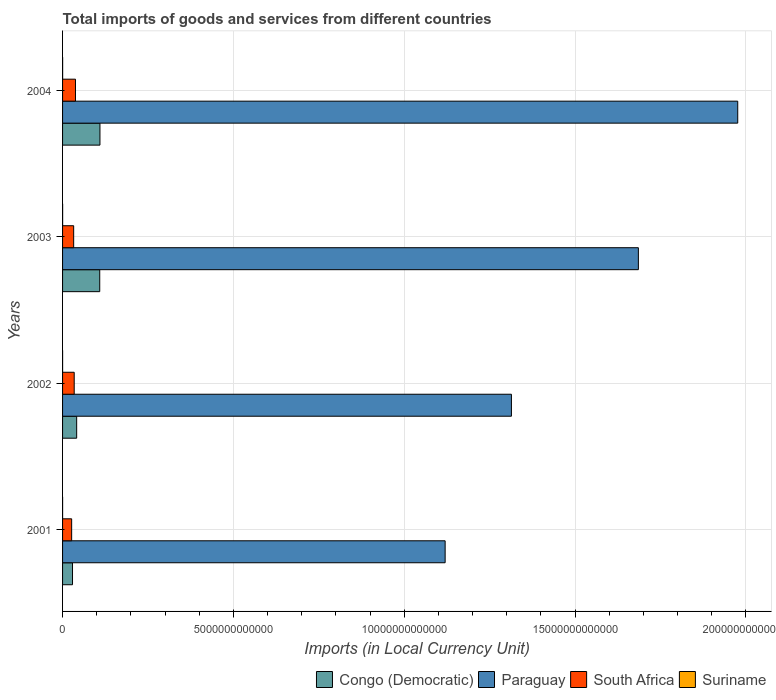Are the number of bars on each tick of the Y-axis equal?
Your response must be concise. Yes. How many bars are there on the 1st tick from the top?
Give a very brief answer. 4. What is the label of the 4th group of bars from the top?
Give a very brief answer. 2001. In how many cases, is the number of bars for a given year not equal to the number of legend labels?
Your answer should be very brief. 0. What is the Amount of goods and services imports in Paraguay in 2002?
Your answer should be compact. 1.31e+13. Across all years, what is the maximum Amount of goods and services imports in South Africa?
Offer a terse response. 3.78e+11. Across all years, what is the minimum Amount of goods and services imports in Congo (Democratic)?
Give a very brief answer. 2.91e+11. In which year was the Amount of goods and services imports in Suriname minimum?
Your answer should be compact. 2001. What is the total Amount of goods and services imports in Paraguay in the graph?
Your response must be concise. 6.10e+13. What is the difference between the Amount of goods and services imports in South Africa in 2003 and that in 2004?
Make the answer very short. -5.31e+1. What is the difference between the Amount of goods and services imports in Congo (Democratic) in 2004 and the Amount of goods and services imports in South Africa in 2003?
Your answer should be compact. 7.69e+11. What is the average Amount of goods and services imports in Paraguay per year?
Offer a very short reply. 1.52e+13. In the year 2002, what is the difference between the Amount of goods and services imports in Congo (Democratic) and Amount of goods and services imports in Suriname?
Keep it short and to the point. 4.12e+11. In how many years, is the Amount of goods and services imports in Congo (Democratic) greater than 8000000000000 LCU?
Provide a short and direct response. 0. What is the ratio of the Amount of goods and services imports in South Africa in 2002 to that in 2004?
Make the answer very short. 0.9. Is the Amount of goods and services imports in Paraguay in 2003 less than that in 2004?
Provide a succinct answer. Yes. Is the difference between the Amount of goods and services imports in Congo (Democratic) in 2002 and 2003 greater than the difference between the Amount of goods and services imports in Suriname in 2002 and 2003?
Keep it short and to the point. No. What is the difference between the highest and the second highest Amount of goods and services imports in South Africa?
Keep it short and to the point. 3.75e+1. What is the difference between the highest and the lowest Amount of goods and services imports in Paraguay?
Your answer should be compact. 8.56e+12. What does the 4th bar from the top in 2002 represents?
Ensure brevity in your answer.  Congo (Democratic). What does the 4th bar from the bottom in 2001 represents?
Make the answer very short. Suriname. Is it the case that in every year, the sum of the Amount of goods and services imports in South Africa and Amount of goods and services imports in Suriname is greater than the Amount of goods and services imports in Congo (Democratic)?
Give a very brief answer. No. Are all the bars in the graph horizontal?
Give a very brief answer. Yes. How many years are there in the graph?
Provide a short and direct response. 4. What is the difference between two consecutive major ticks on the X-axis?
Provide a succinct answer. 5.00e+12. Does the graph contain any zero values?
Give a very brief answer. No. Where does the legend appear in the graph?
Your response must be concise. Bottom right. How many legend labels are there?
Give a very brief answer. 4. How are the legend labels stacked?
Provide a short and direct response. Horizontal. What is the title of the graph?
Give a very brief answer. Total imports of goods and services from different countries. What is the label or title of the X-axis?
Your answer should be compact. Imports (in Local Currency Unit). What is the Imports (in Local Currency Unit) of Congo (Democratic) in 2001?
Give a very brief answer. 2.91e+11. What is the Imports (in Local Currency Unit) in Paraguay in 2001?
Provide a succinct answer. 1.12e+13. What is the Imports (in Local Currency Unit) in South Africa in 2001?
Ensure brevity in your answer.  2.66e+11. What is the Imports (in Local Currency Unit) in Suriname in 2001?
Ensure brevity in your answer.  9.06e+08. What is the Imports (in Local Currency Unit) in Congo (Democratic) in 2002?
Provide a short and direct response. 4.13e+11. What is the Imports (in Local Currency Unit) of Paraguay in 2002?
Your answer should be very brief. 1.31e+13. What is the Imports (in Local Currency Unit) of South Africa in 2002?
Provide a short and direct response. 3.41e+11. What is the Imports (in Local Currency Unit) of Suriname in 2002?
Ensure brevity in your answer.  1.00e+09. What is the Imports (in Local Currency Unit) in Congo (Democratic) in 2003?
Make the answer very short. 1.09e+12. What is the Imports (in Local Currency Unit) of Paraguay in 2003?
Make the answer very short. 1.69e+13. What is the Imports (in Local Currency Unit) in South Africa in 2003?
Your answer should be very brief. 3.25e+11. What is the Imports (in Local Currency Unit) of Suriname in 2003?
Provide a short and direct response. 1.51e+09. What is the Imports (in Local Currency Unit) of Congo (Democratic) in 2004?
Keep it short and to the point. 1.09e+12. What is the Imports (in Local Currency Unit) in Paraguay in 2004?
Offer a terse response. 1.98e+13. What is the Imports (in Local Currency Unit) in South Africa in 2004?
Your response must be concise. 3.78e+11. What is the Imports (in Local Currency Unit) of Suriname in 2004?
Offer a terse response. 1.95e+09. Across all years, what is the maximum Imports (in Local Currency Unit) of Congo (Democratic)?
Offer a very short reply. 1.09e+12. Across all years, what is the maximum Imports (in Local Currency Unit) in Paraguay?
Provide a short and direct response. 1.98e+13. Across all years, what is the maximum Imports (in Local Currency Unit) in South Africa?
Make the answer very short. 3.78e+11. Across all years, what is the maximum Imports (in Local Currency Unit) in Suriname?
Ensure brevity in your answer.  1.95e+09. Across all years, what is the minimum Imports (in Local Currency Unit) in Congo (Democratic)?
Make the answer very short. 2.91e+11. Across all years, what is the minimum Imports (in Local Currency Unit) of Paraguay?
Your answer should be very brief. 1.12e+13. Across all years, what is the minimum Imports (in Local Currency Unit) of South Africa?
Your answer should be compact. 2.66e+11. Across all years, what is the minimum Imports (in Local Currency Unit) in Suriname?
Your answer should be very brief. 9.06e+08. What is the total Imports (in Local Currency Unit) in Congo (Democratic) in the graph?
Give a very brief answer. 2.89e+12. What is the total Imports (in Local Currency Unit) in Paraguay in the graph?
Offer a very short reply. 6.10e+13. What is the total Imports (in Local Currency Unit) of South Africa in the graph?
Your response must be concise. 1.31e+12. What is the total Imports (in Local Currency Unit) of Suriname in the graph?
Your answer should be compact. 5.37e+09. What is the difference between the Imports (in Local Currency Unit) of Congo (Democratic) in 2001 and that in 2002?
Provide a short and direct response. -1.22e+11. What is the difference between the Imports (in Local Currency Unit) of Paraguay in 2001 and that in 2002?
Your answer should be very brief. -1.94e+12. What is the difference between the Imports (in Local Currency Unit) of South Africa in 2001 and that in 2002?
Ensure brevity in your answer.  -7.46e+1. What is the difference between the Imports (in Local Currency Unit) in Suriname in 2001 and that in 2002?
Your response must be concise. -9.74e+07. What is the difference between the Imports (in Local Currency Unit) in Congo (Democratic) in 2001 and that in 2003?
Keep it short and to the point. -7.97e+11. What is the difference between the Imports (in Local Currency Unit) in Paraguay in 2001 and that in 2003?
Your answer should be compact. -5.66e+12. What is the difference between the Imports (in Local Currency Unit) in South Africa in 2001 and that in 2003?
Make the answer very short. -5.90e+1. What is the difference between the Imports (in Local Currency Unit) of Suriname in 2001 and that in 2003?
Your answer should be very brief. -6.00e+08. What is the difference between the Imports (in Local Currency Unit) of Congo (Democratic) in 2001 and that in 2004?
Give a very brief answer. -8.03e+11. What is the difference between the Imports (in Local Currency Unit) of Paraguay in 2001 and that in 2004?
Your response must be concise. -8.56e+12. What is the difference between the Imports (in Local Currency Unit) of South Africa in 2001 and that in 2004?
Provide a succinct answer. -1.12e+11. What is the difference between the Imports (in Local Currency Unit) in Suriname in 2001 and that in 2004?
Give a very brief answer. -1.05e+09. What is the difference between the Imports (in Local Currency Unit) in Congo (Democratic) in 2002 and that in 2003?
Your response must be concise. -6.75e+11. What is the difference between the Imports (in Local Currency Unit) in Paraguay in 2002 and that in 2003?
Your response must be concise. -3.72e+12. What is the difference between the Imports (in Local Currency Unit) in South Africa in 2002 and that in 2003?
Your response must be concise. 1.56e+1. What is the difference between the Imports (in Local Currency Unit) in Suriname in 2002 and that in 2003?
Ensure brevity in your answer.  -5.03e+08. What is the difference between the Imports (in Local Currency Unit) in Congo (Democratic) in 2002 and that in 2004?
Ensure brevity in your answer.  -6.82e+11. What is the difference between the Imports (in Local Currency Unit) of Paraguay in 2002 and that in 2004?
Provide a succinct answer. -6.62e+12. What is the difference between the Imports (in Local Currency Unit) of South Africa in 2002 and that in 2004?
Your answer should be very brief. -3.75e+1. What is the difference between the Imports (in Local Currency Unit) in Suriname in 2002 and that in 2004?
Your answer should be very brief. -9.49e+08. What is the difference between the Imports (in Local Currency Unit) in Congo (Democratic) in 2003 and that in 2004?
Ensure brevity in your answer.  -6.40e+09. What is the difference between the Imports (in Local Currency Unit) in Paraguay in 2003 and that in 2004?
Keep it short and to the point. -2.91e+12. What is the difference between the Imports (in Local Currency Unit) of South Africa in 2003 and that in 2004?
Make the answer very short. -5.31e+1. What is the difference between the Imports (in Local Currency Unit) in Suriname in 2003 and that in 2004?
Make the answer very short. -4.46e+08. What is the difference between the Imports (in Local Currency Unit) of Congo (Democratic) in 2001 and the Imports (in Local Currency Unit) of Paraguay in 2002?
Provide a succinct answer. -1.28e+13. What is the difference between the Imports (in Local Currency Unit) in Congo (Democratic) in 2001 and the Imports (in Local Currency Unit) in South Africa in 2002?
Your response must be concise. -4.93e+1. What is the difference between the Imports (in Local Currency Unit) in Congo (Democratic) in 2001 and the Imports (in Local Currency Unit) in Suriname in 2002?
Offer a terse response. 2.90e+11. What is the difference between the Imports (in Local Currency Unit) of Paraguay in 2001 and the Imports (in Local Currency Unit) of South Africa in 2002?
Make the answer very short. 1.09e+13. What is the difference between the Imports (in Local Currency Unit) in Paraguay in 2001 and the Imports (in Local Currency Unit) in Suriname in 2002?
Ensure brevity in your answer.  1.12e+13. What is the difference between the Imports (in Local Currency Unit) of South Africa in 2001 and the Imports (in Local Currency Unit) of Suriname in 2002?
Offer a very short reply. 2.65e+11. What is the difference between the Imports (in Local Currency Unit) of Congo (Democratic) in 2001 and the Imports (in Local Currency Unit) of Paraguay in 2003?
Offer a very short reply. -1.66e+13. What is the difference between the Imports (in Local Currency Unit) of Congo (Democratic) in 2001 and the Imports (in Local Currency Unit) of South Africa in 2003?
Make the answer very short. -3.37e+1. What is the difference between the Imports (in Local Currency Unit) of Congo (Democratic) in 2001 and the Imports (in Local Currency Unit) of Suriname in 2003?
Offer a terse response. 2.90e+11. What is the difference between the Imports (in Local Currency Unit) in Paraguay in 2001 and the Imports (in Local Currency Unit) in South Africa in 2003?
Keep it short and to the point. 1.09e+13. What is the difference between the Imports (in Local Currency Unit) of Paraguay in 2001 and the Imports (in Local Currency Unit) of Suriname in 2003?
Your answer should be compact. 1.12e+13. What is the difference between the Imports (in Local Currency Unit) of South Africa in 2001 and the Imports (in Local Currency Unit) of Suriname in 2003?
Provide a short and direct response. 2.64e+11. What is the difference between the Imports (in Local Currency Unit) of Congo (Democratic) in 2001 and the Imports (in Local Currency Unit) of Paraguay in 2004?
Offer a terse response. -1.95e+13. What is the difference between the Imports (in Local Currency Unit) of Congo (Democratic) in 2001 and the Imports (in Local Currency Unit) of South Africa in 2004?
Make the answer very short. -8.69e+1. What is the difference between the Imports (in Local Currency Unit) in Congo (Democratic) in 2001 and the Imports (in Local Currency Unit) in Suriname in 2004?
Your answer should be very brief. 2.89e+11. What is the difference between the Imports (in Local Currency Unit) of Paraguay in 2001 and the Imports (in Local Currency Unit) of South Africa in 2004?
Keep it short and to the point. 1.08e+13. What is the difference between the Imports (in Local Currency Unit) of Paraguay in 2001 and the Imports (in Local Currency Unit) of Suriname in 2004?
Offer a very short reply. 1.12e+13. What is the difference between the Imports (in Local Currency Unit) in South Africa in 2001 and the Imports (in Local Currency Unit) in Suriname in 2004?
Keep it short and to the point. 2.64e+11. What is the difference between the Imports (in Local Currency Unit) in Congo (Democratic) in 2002 and the Imports (in Local Currency Unit) in Paraguay in 2003?
Offer a very short reply. -1.64e+13. What is the difference between the Imports (in Local Currency Unit) of Congo (Democratic) in 2002 and the Imports (in Local Currency Unit) of South Africa in 2003?
Offer a terse response. 8.79e+1. What is the difference between the Imports (in Local Currency Unit) in Congo (Democratic) in 2002 and the Imports (in Local Currency Unit) in Suriname in 2003?
Your answer should be compact. 4.11e+11. What is the difference between the Imports (in Local Currency Unit) in Paraguay in 2002 and the Imports (in Local Currency Unit) in South Africa in 2003?
Give a very brief answer. 1.28e+13. What is the difference between the Imports (in Local Currency Unit) of Paraguay in 2002 and the Imports (in Local Currency Unit) of Suriname in 2003?
Your answer should be compact. 1.31e+13. What is the difference between the Imports (in Local Currency Unit) of South Africa in 2002 and the Imports (in Local Currency Unit) of Suriname in 2003?
Offer a very short reply. 3.39e+11. What is the difference between the Imports (in Local Currency Unit) of Congo (Democratic) in 2002 and the Imports (in Local Currency Unit) of Paraguay in 2004?
Provide a succinct answer. -1.93e+13. What is the difference between the Imports (in Local Currency Unit) of Congo (Democratic) in 2002 and the Imports (in Local Currency Unit) of South Africa in 2004?
Keep it short and to the point. 3.47e+1. What is the difference between the Imports (in Local Currency Unit) of Congo (Democratic) in 2002 and the Imports (in Local Currency Unit) of Suriname in 2004?
Ensure brevity in your answer.  4.11e+11. What is the difference between the Imports (in Local Currency Unit) in Paraguay in 2002 and the Imports (in Local Currency Unit) in South Africa in 2004?
Provide a short and direct response. 1.28e+13. What is the difference between the Imports (in Local Currency Unit) of Paraguay in 2002 and the Imports (in Local Currency Unit) of Suriname in 2004?
Make the answer very short. 1.31e+13. What is the difference between the Imports (in Local Currency Unit) of South Africa in 2002 and the Imports (in Local Currency Unit) of Suriname in 2004?
Your answer should be compact. 3.39e+11. What is the difference between the Imports (in Local Currency Unit) in Congo (Democratic) in 2003 and the Imports (in Local Currency Unit) in Paraguay in 2004?
Offer a very short reply. -1.87e+13. What is the difference between the Imports (in Local Currency Unit) of Congo (Democratic) in 2003 and the Imports (in Local Currency Unit) of South Africa in 2004?
Offer a very short reply. 7.10e+11. What is the difference between the Imports (in Local Currency Unit) in Congo (Democratic) in 2003 and the Imports (in Local Currency Unit) in Suriname in 2004?
Keep it short and to the point. 1.09e+12. What is the difference between the Imports (in Local Currency Unit) of Paraguay in 2003 and the Imports (in Local Currency Unit) of South Africa in 2004?
Provide a short and direct response. 1.65e+13. What is the difference between the Imports (in Local Currency Unit) in Paraguay in 2003 and the Imports (in Local Currency Unit) in Suriname in 2004?
Make the answer very short. 1.69e+13. What is the difference between the Imports (in Local Currency Unit) of South Africa in 2003 and the Imports (in Local Currency Unit) of Suriname in 2004?
Offer a very short reply. 3.23e+11. What is the average Imports (in Local Currency Unit) of Congo (Democratic) per year?
Your response must be concise. 7.22e+11. What is the average Imports (in Local Currency Unit) in Paraguay per year?
Your answer should be compact. 1.52e+13. What is the average Imports (in Local Currency Unit) in South Africa per year?
Your answer should be very brief. 3.27e+11. What is the average Imports (in Local Currency Unit) in Suriname per year?
Make the answer very short. 1.34e+09. In the year 2001, what is the difference between the Imports (in Local Currency Unit) of Congo (Democratic) and Imports (in Local Currency Unit) of Paraguay?
Your response must be concise. -1.09e+13. In the year 2001, what is the difference between the Imports (in Local Currency Unit) in Congo (Democratic) and Imports (in Local Currency Unit) in South Africa?
Your answer should be compact. 2.53e+1. In the year 2001, what is the difference between the Imports (in Local Currency Unit) of Congo (Democratic) and Imports (in Local Currency Unit) of Suriname?
Ensure brevity in your answer.  2.90e+11. In the year 2001, what is the difference between the Imports (in Local Currency Unit) in Paraguay and Imports (in Local Currency Unit) in South Africa?
Give a very brief answer. 1.09e+13. In the year 2001, what is the difference between the Imports (in Local Currency Unit) in Paraguay and Imports (in Local Currency Unit) in Suriname?
Your answer should be compact. 1.12e+13. In the year 2001, what is the difference between the Imports (in Local Currency Unit) of South Africa and Imports (in Local Currency Unit) of Suriname?
Offer a very short reply. 2.65e+11. In the year 2002, what is the difference between the Imports (in Local Currency Unit) in Congo (Democratic) and Imports (in Local Currency Unit) in Paraguay?
Ensure brevity in your answer.  -1.27e+13. In the year 2002, what is the difference between the Imports (in Local Currency Unit) of Congo (Democratic) and Imports (in Local Currency Unit) of South Africa?
Provide a succinct answer. 7.23e+1. In the year 2002, what is the difference between the Imports (in Local Currency Unit) of Congo (Democratic) and Imports (in Local Currency Unit) of Suriname?
Keep it short and to the point. 4.12e+11. In the year 2002, what is the difference between the Imports (in Local Currency Unit) of Paraguay and Imports (in Local Currency Unit) of South Africa?
Give a very brief answer. 1.28e+13. In the year 2002, what is the difference between the Imports (in Local Currency Unit) of Paraguay and Imports (in Local Currency Unit) of Suriname?
Make the answer very short. 1.31e+13. In the year 2002, what is the difference between the Imports (in Local Currency Unit) of South Africa and Imports (in Local Currency Unit) of Suriname?
Your answer should be very brief. 3.40e+11. In the year 2003, what is the difference between the Imports (in Local Currency Unit) of Congo (Democratic) and Imports (in Local Currency Unit) of Paraguay?
Offer a terse response. -1.58e+13. In the year 2003, what is the difference between the Imports (in Local Currency Unit) of Congo (Democratic) and Imports (in Local Currency Unit) of South Africa?
Offer a very short reply. 7.63e+11. In the year 2003, what is the difference between the Imports (in Local Currency Unit) of Congo (Democratic) and Imports (in Local Currency Unit) of Suriname?
Provide a succinct answer. 1.09e+12. In the year 2003, what is the difference between the Imports (in Local Currency Unit) of Paraguay and Imports (in Local Currency Unit) of South Africa?
Your answer should be very brief. 1.65e+13. In the year 2003, what is the difference between the Imports (in Local Currency Unit) in Paraguay and Imports (in Local Currency Unit) in Suriname?
Provide a short and direct response. 1.69e+13. In the year 2003, what is the difference between the Imports (in Local Currency Unit) in South Africa and Imports (in Local Currency Unit) in Suriname?
Your answer should be compact. 3.24e+11. In the year 2004, what is the difference between the Imports (in Local Currency Unit) of Congo (Democratic) and Imports (in Local Currency Unit) of Paraguay?
Your answer should be compact. -1.87e+13. In the year 2004, what is the difference between the Imports (in Local Currency Unit) of Congo (Democratic) and Imports (in Local Currency Unit) of South Africa?
Provide a succinct answer. 7.16e+11. In the year 2004, what is the difference between the Imports (in Local Currency Unit) of Congo (Democratic) and Imports (in Local Currency Unit) of Suriname?
Provide a short and direct response. 1.09e+12. In the year 2004, what is the difference between the Imports (in Local Currency Unit) of Paraguay and Imports (in Local Currency Unit) of South Africa?
Offer a terse response. 1.94e+13. In the year 2004, what is the difference between the Imports (in Local Currency Unit) in Paraguay and Imports (in Local Currency Unit) in Suriname?
Make the answer very short. 1.98e+13. In the year 2004, what is the difference between the Imports (in Local Currency Unit) of South Africa and Imports (in Local Currency Unit) of Suriname?
Keep it short and to the point. 3.76e+11. What is the ratio of the Imports (in Local Currency Unit) of Congo (Democratic) in 2001 to that in 2002?
Provide a short and direct response. 0.71. What is the ratio of the Imports (in Local Currency Unit) in Paraguay in 2001 to that in 2002?
Make the answer very short. 0.85. What is the ratio of the Imports (in Local Currency Unit) in South Africa in 2001 to that in 2002?
Keep it short and to the point. 0.78. What is the ratio of the Imports (in Local Currency Unit) of Suriname in 2001 to that in 2002?
Provide a succinct answer. 0.9. What is the ratio of the Imports (in Local Currency Unit) in Congo (Democratic) in 2001 to that in 2003?
Keep it short and to the point. 0.27. What is the ratio of the Imports (in Local Currency Unit) in Paraguay in 2001 to that in 2003?
Make the answer very short. 0.66. What is the ratio of the Imports (in Local Currency Unit) of South Africa in 2001 to that in 2003?
Provide a short and direct response. 0.82. What is the ratio of the Imports (in Local Currency Unit) in Suriname in 2001 to that in 2003?
Keep it short and to the point. 0.6. What is the ratio of the Imports (in Local Currency Unit) of Congo (Democratic) in 2001 to that in 2004?
Offer a terse response. 0.27. What is the ratio of the Imports (in Local Currency Unit) in Paraguay in 2001 to that in 2004?
Your response must be concise. 0.57. What is the ratio of the Imports (in Local Currency Unit) of South Africa in 2001 to that in 2004?
Give a very brief answer. 0.7. What is the ratio of the Imports (in Local Currency Unit) of Suriname in 2001 to that in 2004?
Provide a succinct answer. 0.46. What is the ratio of the Imports (in Local Currency Unit) in Congo (Democratic) in 2002 to that in 2003?
Keep it short and to the point. 0.38. What is the ratio of the Imports (in Local Currency Unit) of Paraguay in 2002 to that in 2003?
Provide a succinct answer. 0.78. What is the ratio of the Imports (in Local Currency Unit) in South Africa in 2002 to that in 2003?
Provide a short and direct response. 1.05. What is the ratio of the Imports (in Local Currency Unit) in Suriname in 2002 to that in 2003?
Offer a terse response. 0.67. What is the ratio of the Imports (in Local Currency Unit) in Congo (Democratic) in 2002 to that in 2004?
Give a very brief answer. 0.38. What is the ratio of the Imports (in Local Currency Unit) in Paraguay in 2002 to that in 2004?
Offer a terse response. 0.66. What is the ratio of the Imports (in Local Currency Unit) in South Africa in 2002 to that in 2004?
Make the answer very short. 0.9. What is the ratio of the Imports (in Local Currency Unit) of Suriname in 2002 to that in 2004?
Provide a short and direct response. 0.51. What is the ratio of the Imports (in Local Currency Unit) of Paraguay in 2003 to that in 2004?
Give a very brief answer. 0.85. What is the ratio of the Imports (in Local Currency Unit) in South Africa in 2003 to that in 2004?
Ensure brevity in your answer.  0.86. What is the ratio of the Imports (in Local Currency Unit) of Suriname in 2003 to that in 2004?
Offer a terse response. 0.77. What is the difference between the highest and the second highest Imports (in Local Currency Unit) in Congo (Democratic)?
Give a very brief answer. 6.40e+09. What is the difference between the highest and the second highest Imports (in Local Currency Unit) in Paraguay?
Give a very brief answer. 2.91e+12. What is the difference between the highest and the second highest Imports (in Local Currency Unit) in South Africa?
Give a very brief answer. 3.75e+1. What is the difference between the highest and the second highest Imports (in Local Currency Unit) in Suriname?
Ensure brevity in your answer.  4.46e+08. What is the difference between the highest and the lowest Imports (in Local Currency Unit) of Congo (Democratic)?
Keep it short and to the point. 8.03e+11. What is the difference between the highest and the lowest Imports (in Local Currency Unit) of Paraguay?
Your response must be concise. 8.56e+12. What is the difference between the highest and the lowest Imports (in Local Currency Unit) of South Africa?
Your response must be concise. 1.12e+11. What is the difference between the highest and the lowest Imports (in Local Currency Unit) of Suriname?
Offer a terse response. 1.05e+09. 